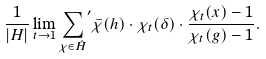Convert formula to latex. <formula><loc_0><loc_0><loc_500><loc_500>\frac { 1 } { | H | } \lim _ { t \to 1 } { \sum _ { \chi \in \hat { H } } } ^ { \prime } \bar { \chi } ( h ) \cdot \chi _ { t } ( \delta ) \cdot \frac { \chi _ { t } ( x ) - 1 } { \chi _ { t } ( g ) - 1 } .</formula> 